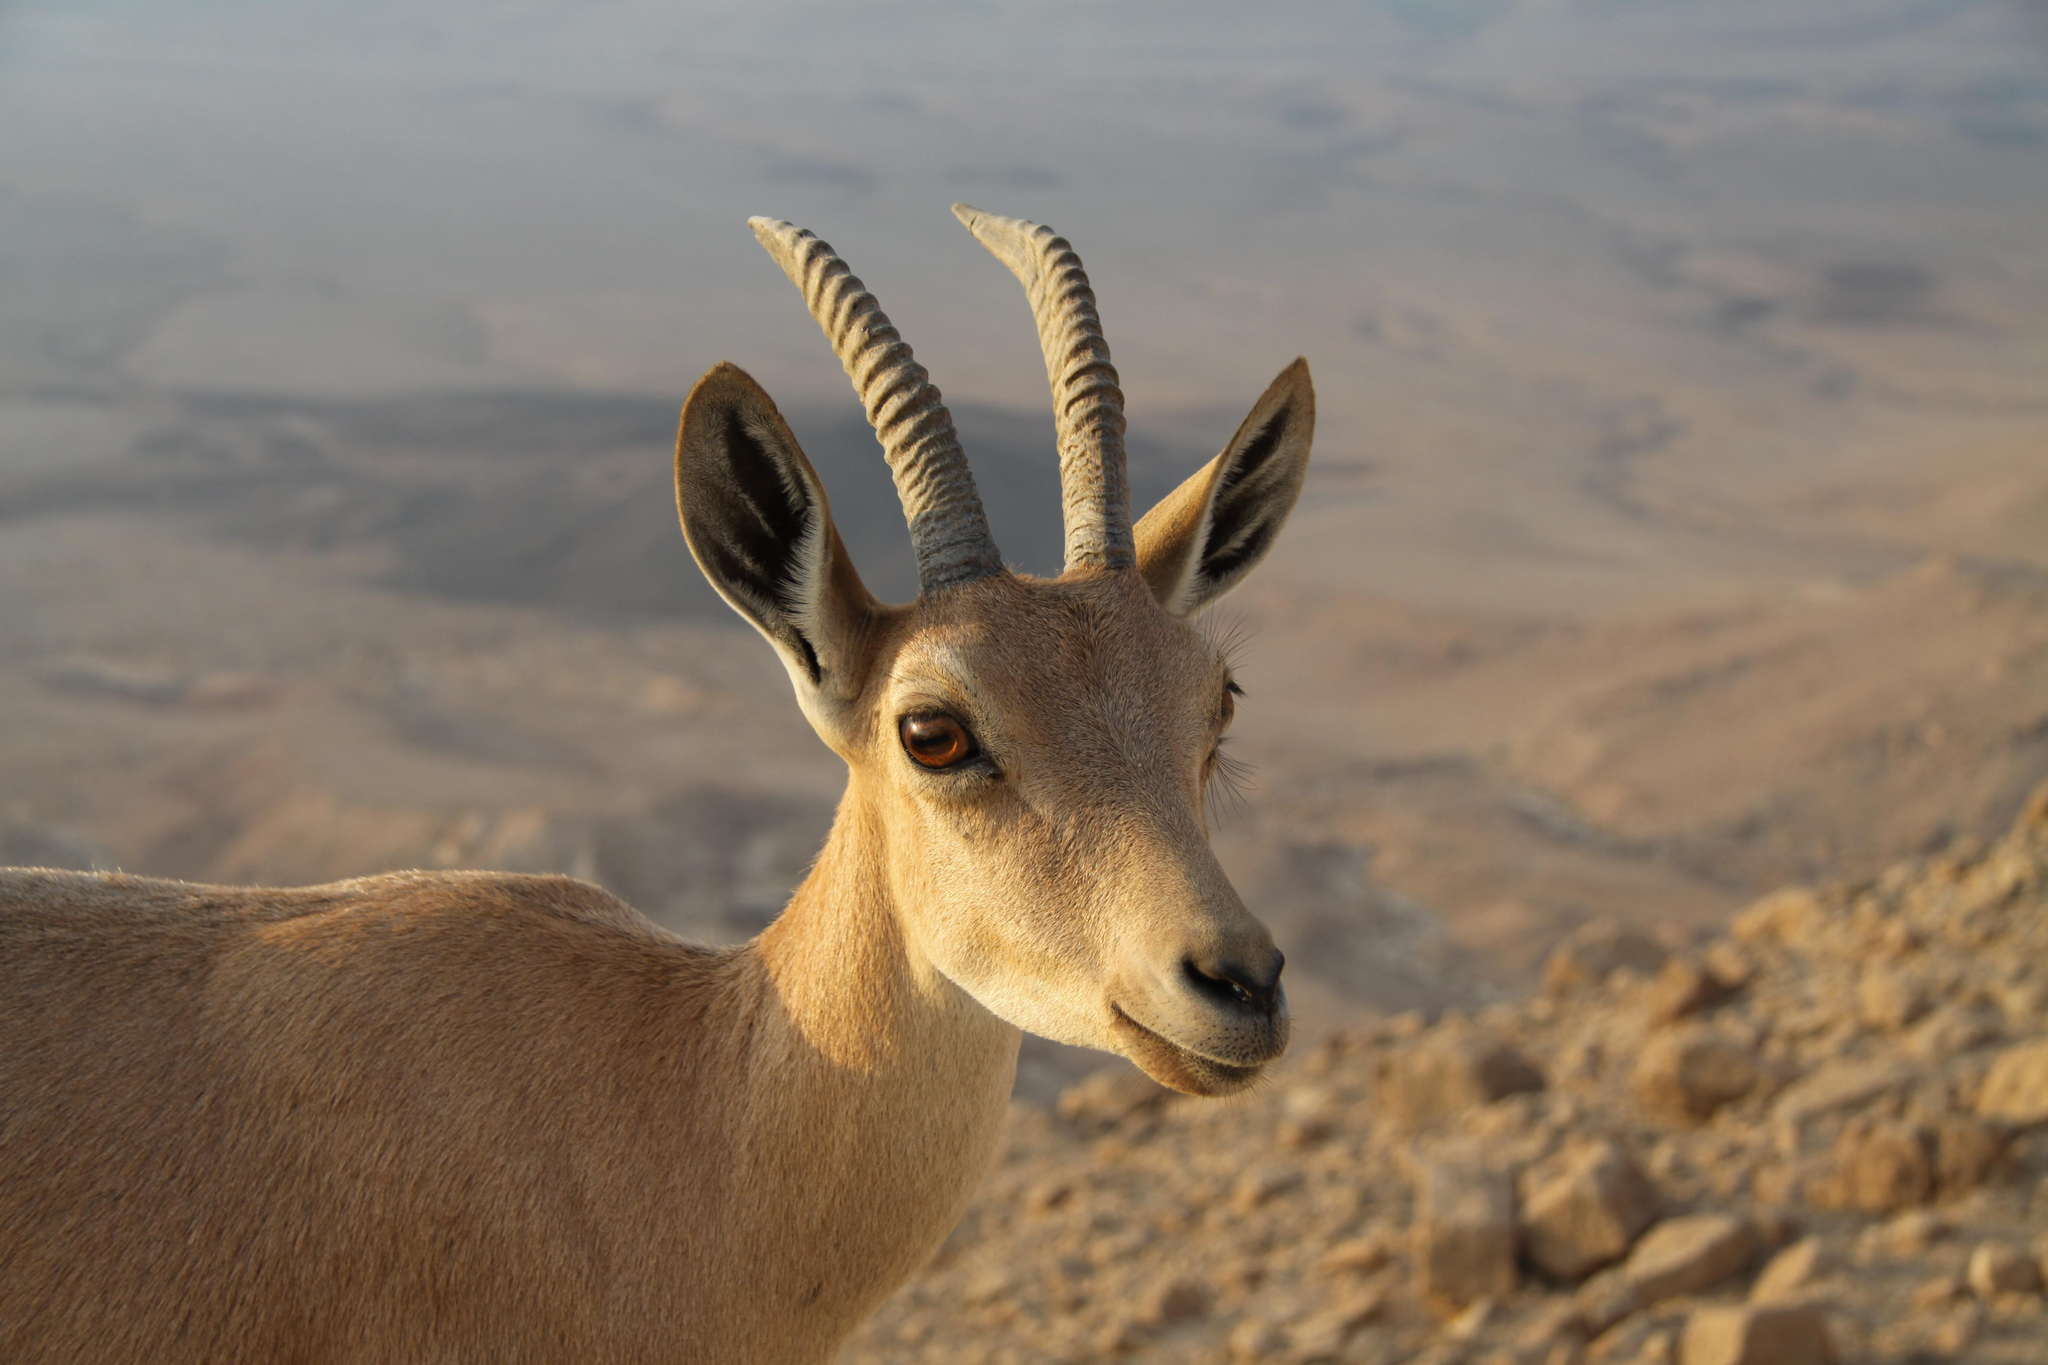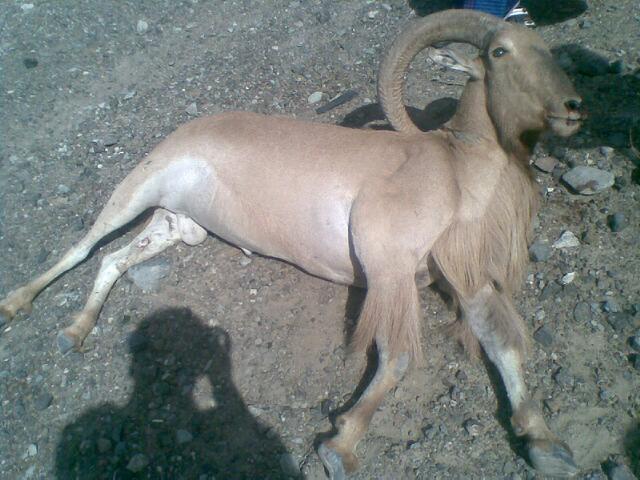The first image is the image on the left, the second image is the image on the right. Assess this claim about the two images: "There is an animal lying on the ground in one of the images.". Correct or not? Answer yes or no. Yes. 